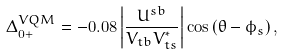Convert formula to latex. <formula><loc_0><loc_0><loc_500><loc_500>\Delta _ { 0 + } ^ { V Q M } = - 0 . 0 8 \left | \frac { U ^ { s b } } { V _ { t b } V _ { t s } ^ { * } } \right | \cos { ( \theta - \phi _ { s } ) } \, ,</formula> 